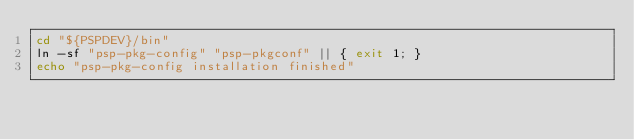Convert code to text. <code><loc_0><loc_0><loc_500><loc_500><_Bash_>cd "${PSPDEV}/bin"
ln -sf "psp-pkg-config" "psp-pkgconf" || { exit 1; }
echo "psp-pkg-config installation finished"
</code> 